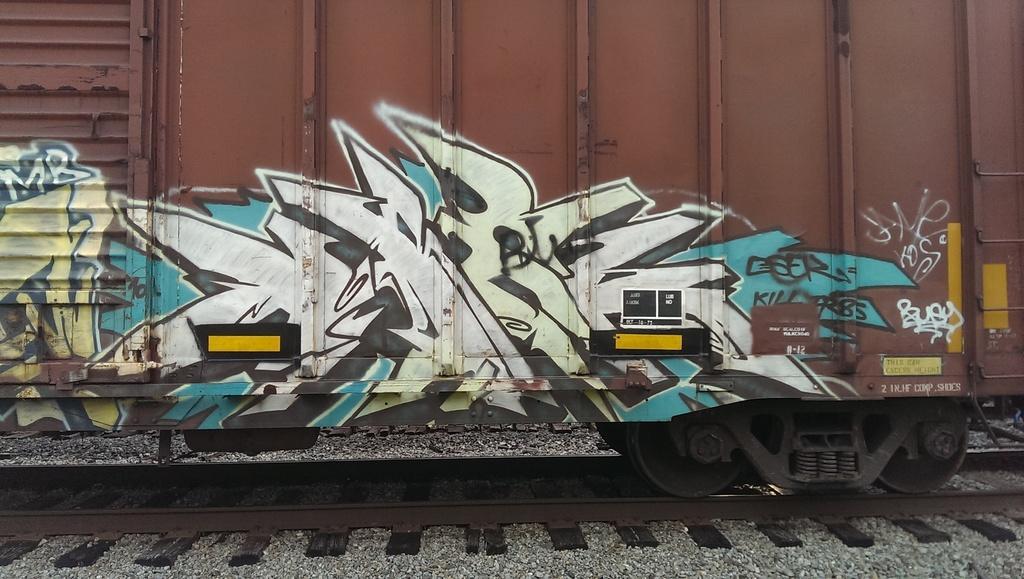How would you summarize this image in a sentence or two? In this image we can see some Graffiti on a train which is on the track. We can also see some stones. 